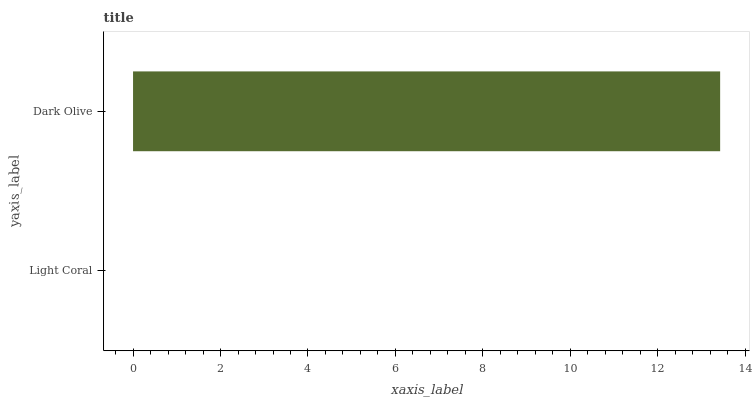Is Light Coral the minimum?
Answer yes or no. Yes. Is Dark Olive the maximum?
Answer yes or no. Yes. Is Dark Olive the minimum?
Answer yes or no. No. Is Dark Olive greater than Light Coral?
Answer yes or no. Yes. Is Light Coral less than Dark Olive?
Answer yes or no. Yes. Is Light Coral greater than Dark Olive?
Answer yes or no. No. Is Dark Olive less than Light Coral?
Answer yes or no. No. Is Dark Olive the high median?
Answer yes or no. Yes. Is Light Coral the low median?
Answer yes or no. Yes. Is Light Coral the high median?
Answer yes or no. No. Is Dark Olive the low median?
Answer yes or no. No. 